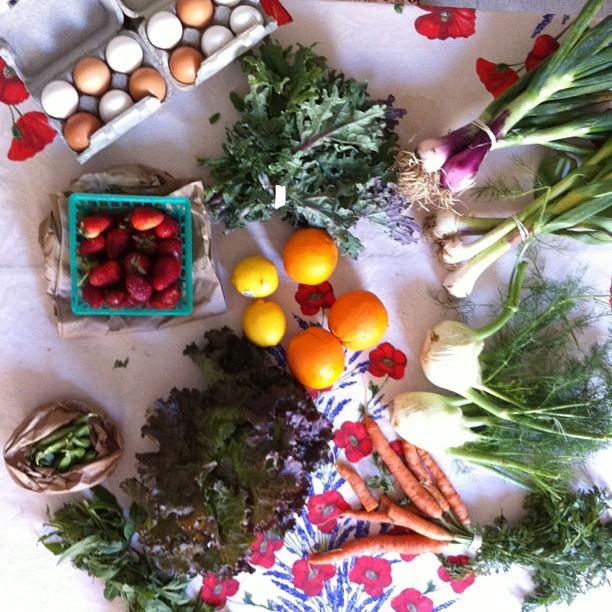What kind of vegetables are in here?
Write a very short answer. Carrots. Are all of the eggs the same color?
Keep it brief. No. What season can we infer it is?
Be succinct. Summer. Is this meat?
Write a very short answer. No. 